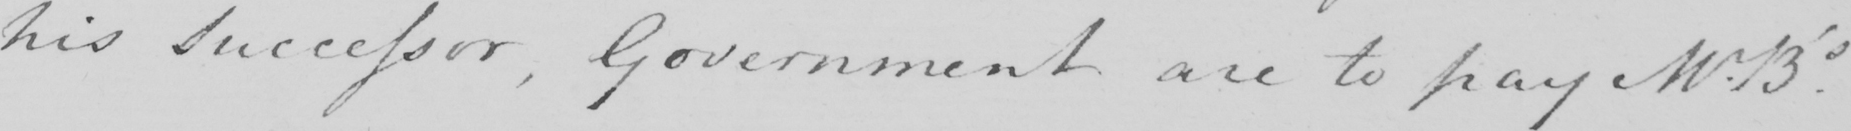Please transcribe the handwritten text in this image. his Successor  , Government are to pay Mr.B ' s . 